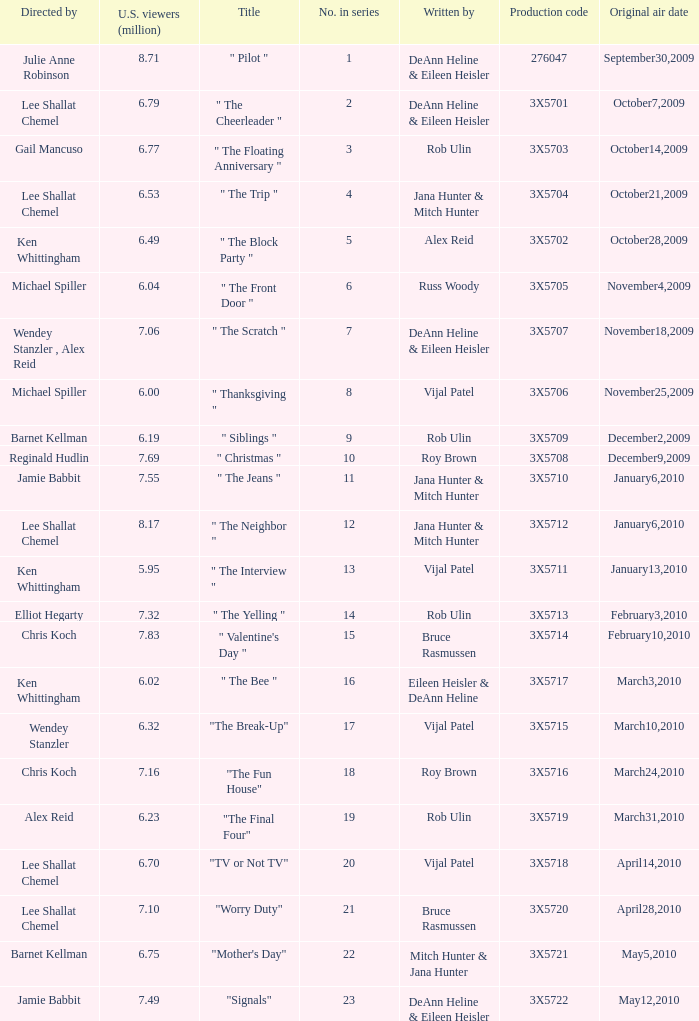How many million U.S. viewers saw the episode with production code 3X5710? 7.55. 